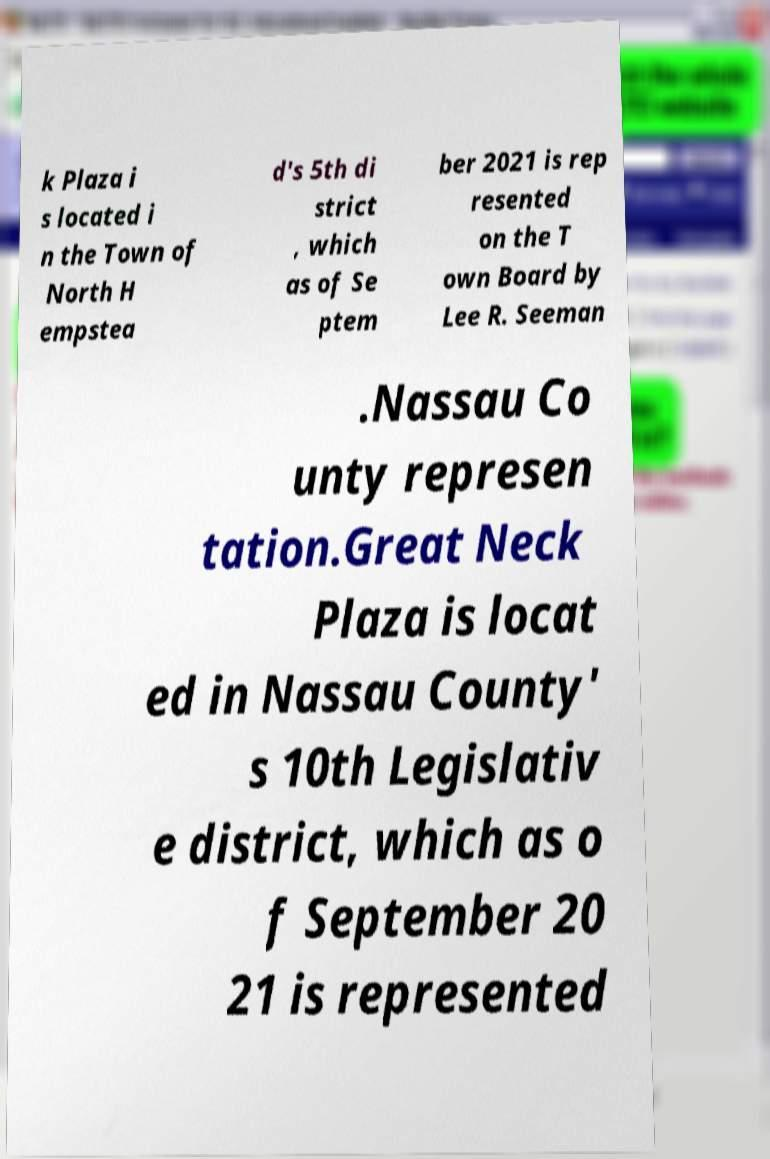For documentation purposes, I need the text within this image transcribed. Could you provide that? k Plaza i s located i n the Town of North H empstea d's 5th di strict , which as of Se ptem ber 2021 is rep resented on the T own Board by Lee R. Seeman .Nassau Co unty represen tation.Great Neck Plaza is locat ed in Nassau County' s 10th Legislativ e district, which as o f September 20 21 is represented 